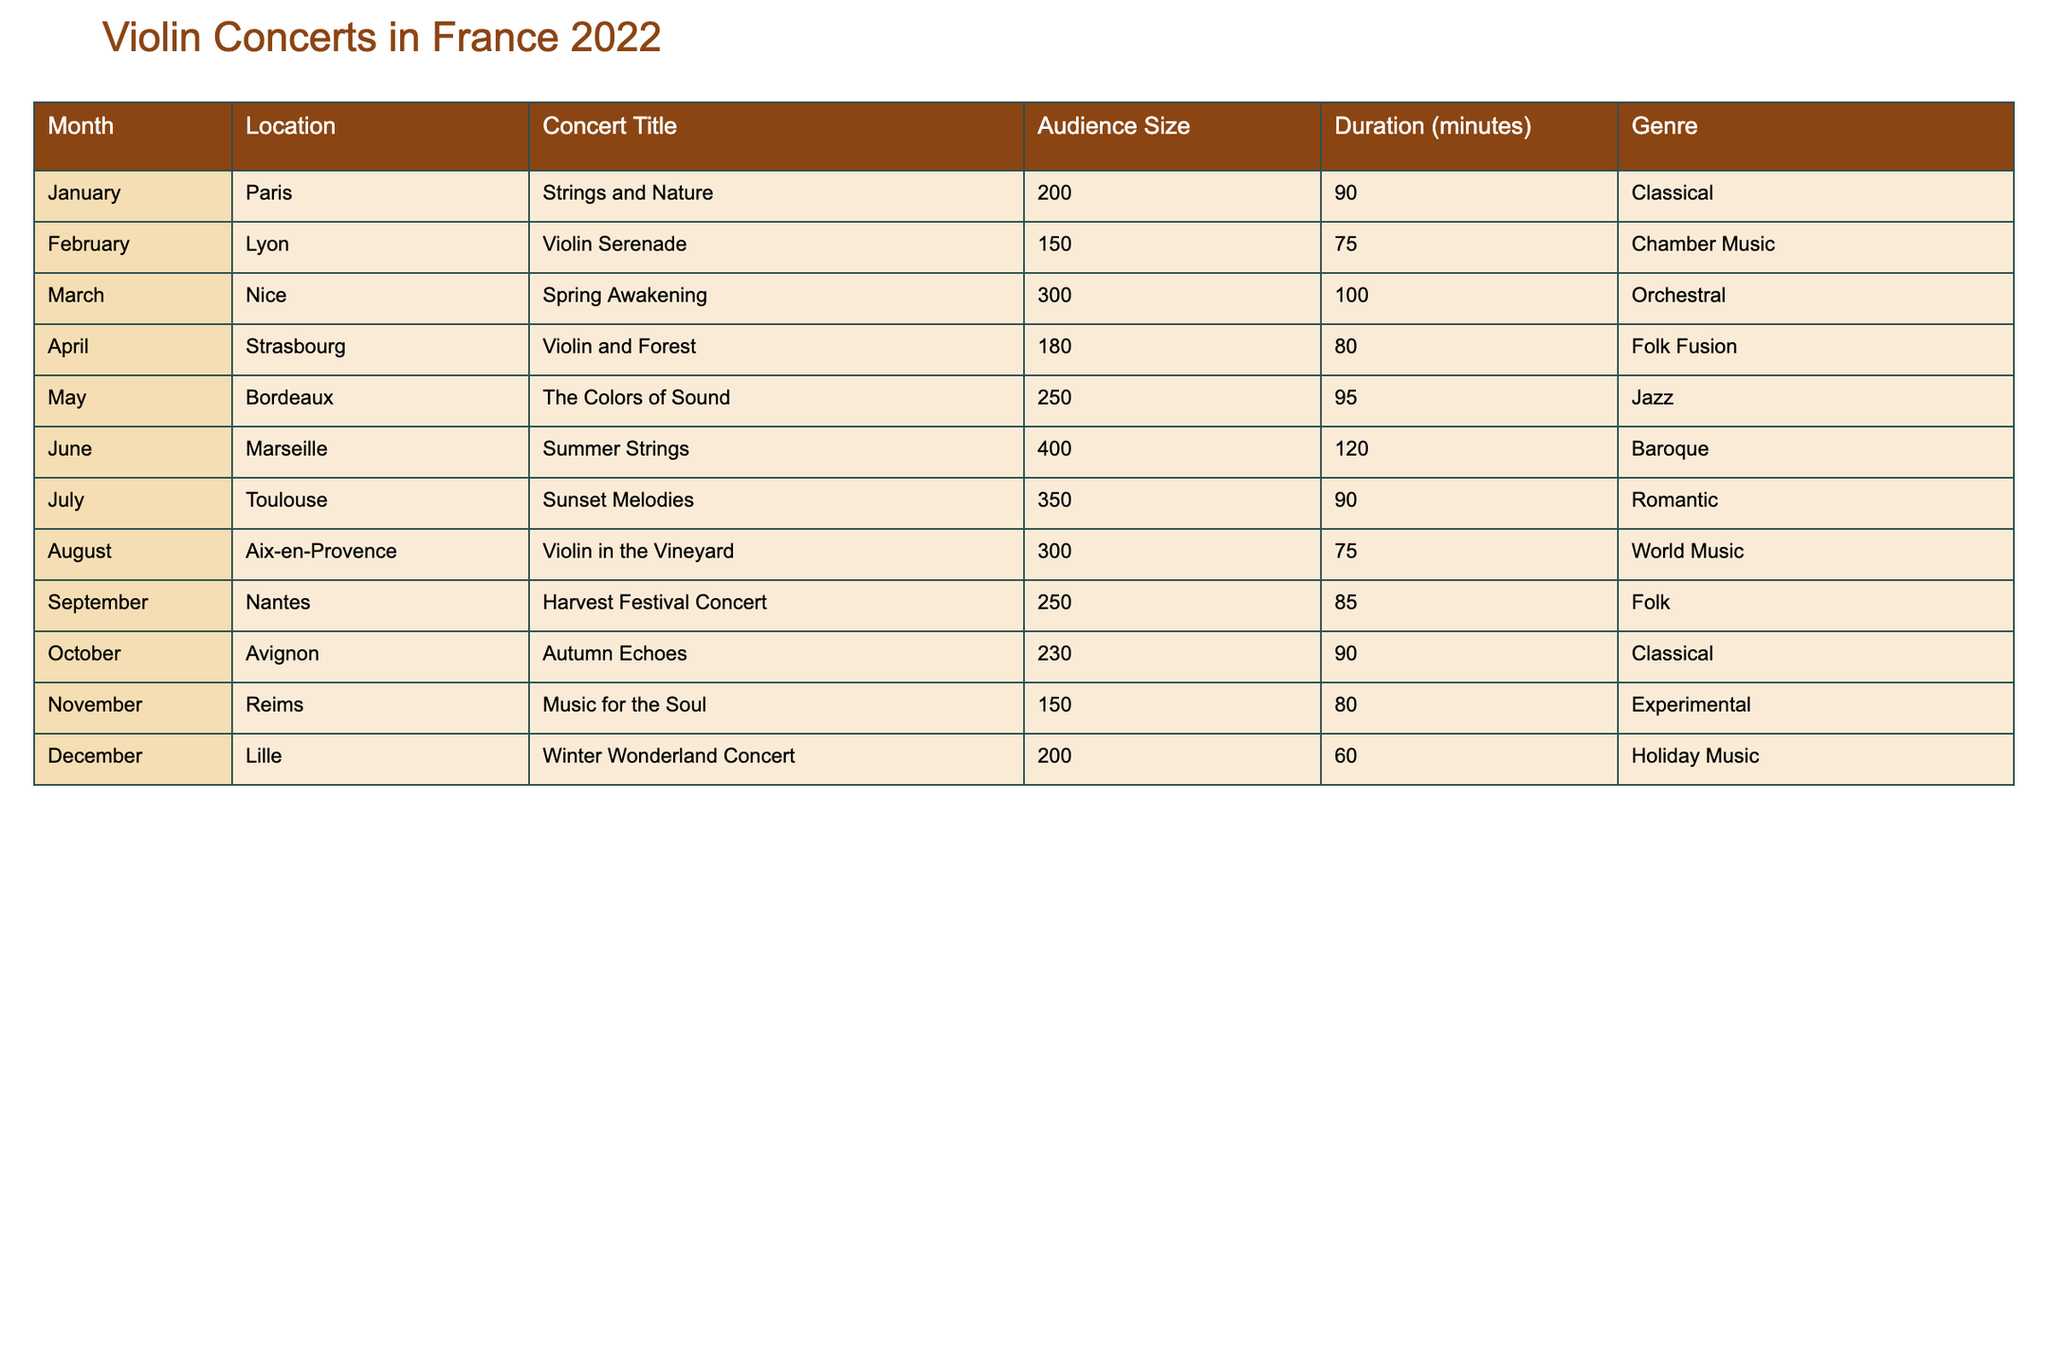What was the title of the concert held in Lyon? The table lists the concert titles for each month and location. For February in Lyon, the concert title is "Violin Serenade".
Answer: Violin Serenade Which concert had the largest audience size? By examining the audience sizes listed in the table, the concert in Marseille in June had the largest audience size of 400.
Answer: 400 What is the total audience size for concerts in the first half of the year? The concerts from January to June have audience sizes of 200, 150, 300, 180, 250, and 400. The total audience size is 200 + 150 + 300 + 180 + 250 + 400 = 1480.
Answer: 1480 How many concerts had a duration of more than 90 minutes? The table lists concert durations for each concert. The concerts lasting more than 90 minutes are in Marseille (120), Toulouse (90), and Nice (100). Counting these, we have 3 concerts.
Answer: 3 Was there a concert titled "Violin in the Vineyard"? Looking through the concert titles in the table, the concert titled "Violin in the Vineyard" was indeed performed in Aix-en-Provence in August.
Answer: Yes What was the average audience size for concerts in the last quarter of the year? The last quarter includes concerts from October to December with audience sizes of 230, 150, and 200. Adding these gives 230 + 150 + 200 = 580. Dividing by the number of concerts (3) gives 580 / 3 = 193.33, which rounds to 193.
Answer: 193 Which month had the second highest audience size? The audience sizes from highest to lowest are 400 (June), 350 (July), 300 (March, August), and the second highest is July's audience size of 350.
Answer: 350 Did any concert feature a genre related to nature? Referring to the genres listed in the table, the concert titled "Violin and Forest" in April has a genre of Folk Fusion, which relates to nature.
Answer: Yes If we consider only classical concerts, what is the average duration? The classical concerts are in January (90 minutes) and October (90 minutes). We calculate the average by summing the durations: 90 + 90 = 180, then dividing by 2 gives 180 / 2 = 90.
Answer: 90 What concert was performed in Nantes and what was its genre? From the table, the concert performed in Nantes was the "Harvest Festival Concert" with a genre of Folk.
Answer: Harvest Festival Concert, Folk Which concert had the shortest duration? Checking the durations in the table, the concert in Lille in December had the shortest duration of 60 minutes.
Answer: 60 